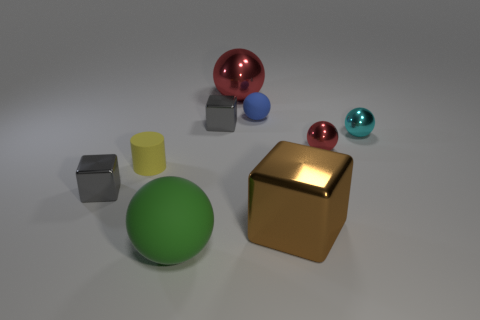Subtract all tiny gray blocks. How many blocks are left? 1 Subtract all purple cubes. How many red spheres are left? 2 Subtract all red balls. How many balls are left? 3 Add 1 large metallic cubes. How many objects exist? 10 Subtract all cylinders. How many objects are left? 8 Subtract all yellow balls. Subtract all green cylinders. How many balls are left? 5 Subtract all red spheres. Subtract all yellow rubber objects. How many objects are left? 6 Add 8 blue rubber balls. How many blue rubber balls are left? 9 Add 6 green matte spheres. How many green matte spheres exist? 7 Subtract 0 green blocks. How many objects are left? 9 